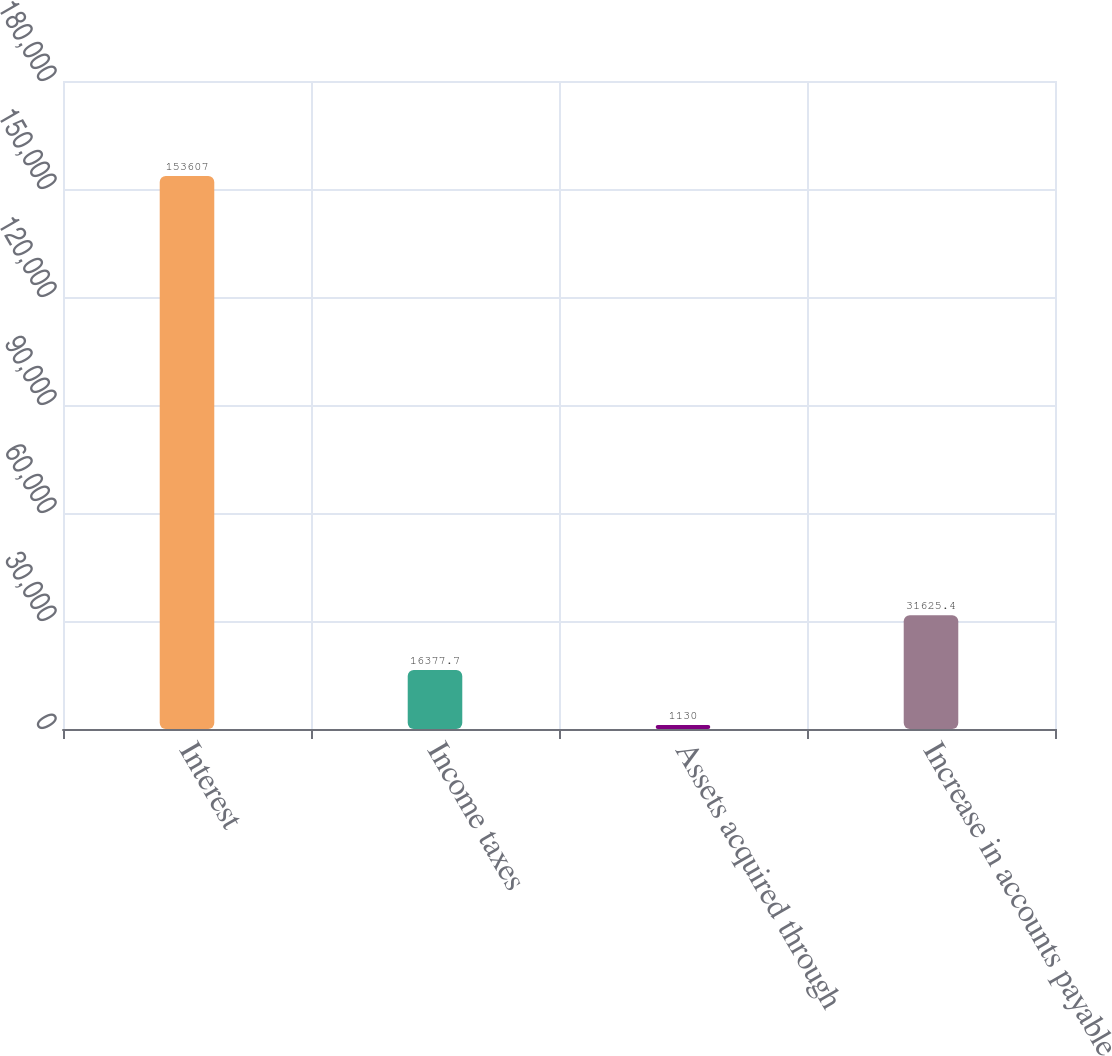<chart> <loc_0><loc_0><loc_500><loc_500><bar_chart><fcel>Interest<fcel>Income taxes<fcel>Assets acquired through<fcel>Increase in accounts payable<nl><fcel>153607<fcel>16377.7<fcel>1130<fcel>31625.4<nl></chart> 